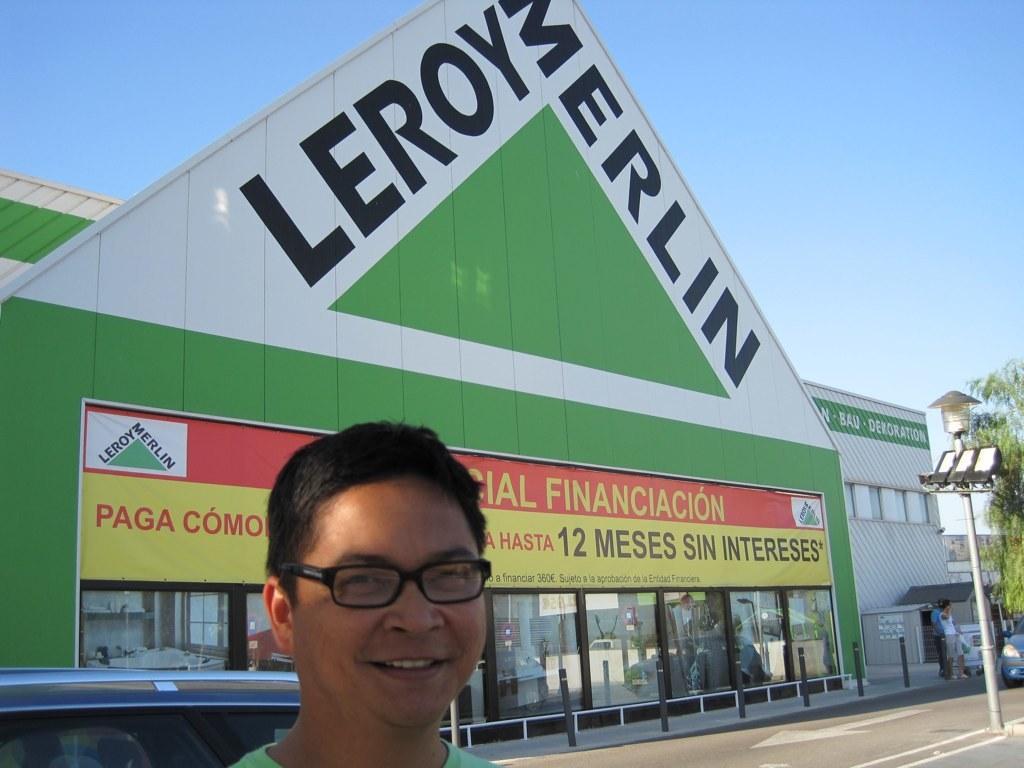Describe this image in one or two sentences. In this image I can see a person wearing green colored t shirt and black colored spectacles is smiling. In the background I can see the road, few vehicles on the road, few persons standing on the side walk, a building which is green and white in color, a light pole, a tree and the sky. 